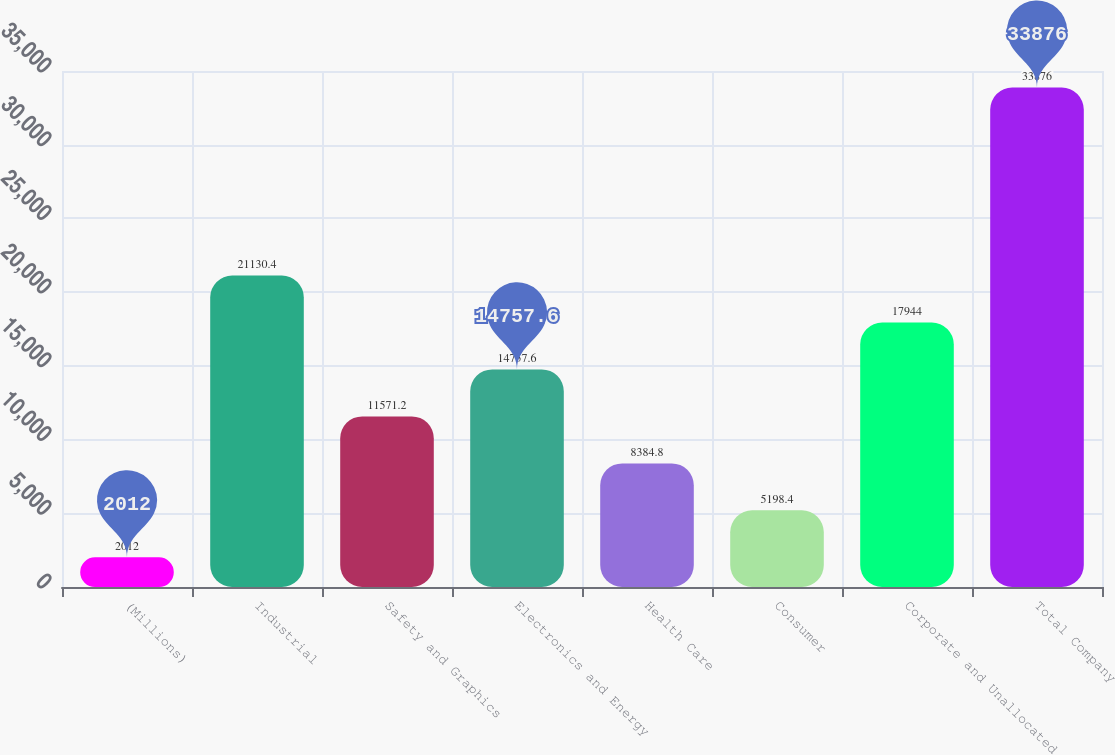Convert chart to OTSL. <chart><loc_0><loc_0><loc_500><loc_500><bar_chart><fcel>(Millions)<fcel>Industrial<fcel>Safety and Graphics<fcel>Electronics and Energy<fcel>Health Care<fcel>Consumer<fcel>Corporate and Unallocated<fcel>Total Company<nl><fcel>2012<fcel>21130.4<fcel>11571.2<fcel>14757.6<fcel>8384.8<fcel>5198.4<fcel>17944<fcel>33876<nl></chart> 